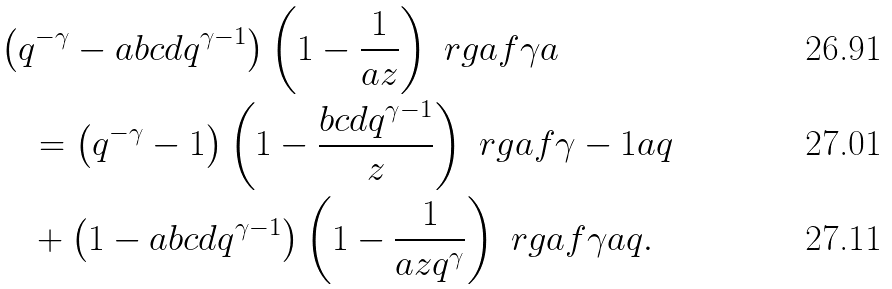Convert formula to latex. <formula><loc_0><loc_0><loc_500><loc_500>& \left ( q ^ { - \gamma } - a b c d q ^ { \gamma - 1 } \right ) \left ( 1 - \frac { 1 } { a z } \right ) \ r g a f { \gamma } { a } \\ & \quad = \left ( q ^ { - \gamma } - 1 \right ) \left ( 1 - \frac { b c d q ^ { \gamma - 1 } } { z } \right ) \ r g a f { \gamma - 1 } { a q } \\ & \quad + \left ( 1 - a b c d q ^ { \gamma - 1 } \right ) \left ( 1 - \frac { 1 } { a z q ^ { \gamma } } \right ) \ r g a f { \gamma } { a q } .</formula> 